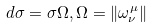<formula> <loc_0><loc_0><loc_500><loc_500>d \sigma = \sigma \Omega , \Omega = \| \omega _ { \nu } ^ { \mu } \|</formula> 